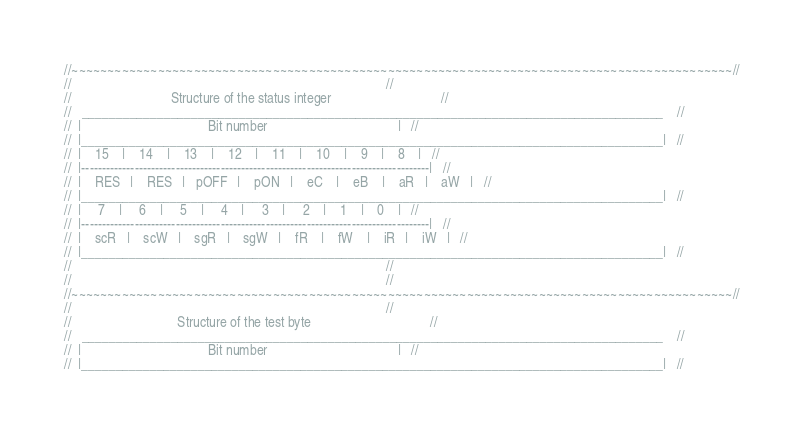Convert code to text. <code><loc_0><loc_0><loc_500><loc_500><_C++_>//~~~~~~~~~~~~~~~~~~~~~~~~~~~~~~~~~~~~~~~~~~~~~~~~~~~~~~~~~~~~~~~~~~~~~~~~~~~~~~~~~~~~~~~~~~~~//
//                                                                                            //
//                             Structure of the status integer                                //
//   _____________________________________________________________________________________    //
//  |                                     Bit number                                      |   //
//  |_____________________________________________________________________________________|   //
//  |    15    |    14    |    13    |    12    |    11    |    10    |    9    |    8    |   //
//  |-------------------------------------------------------------------------------------|   //
//  |    RES   |    RES   |   pOFF   |    pON   |    eC    |    eB    |    aR   |    aW   |   //
//  |_____________________________________________________________________________________|   //
//  |     7    |     6    |     5    |     4    |     3    |     2    |    1    |    0    |   //
//  |-------------------------------------------------------------------------------------|   //
//  |    scR   |    scW   |    sgR   |    sgW   |    fR    |    fW    |    iR   |    iW   |   //
//  |_____________________________________________________________________________________|   //
//                                                                                            //
//                                                                                            //
//~~~~~~~~~~~~~~~~~~~~~~~~~~~~~~~~~~~~~~~~~~~~~~~~~~~~~~~~~~~~~~~~~~~~~~~~~~~~~~~~~~~~~~~~~~~~//
//                                                                                            //
//                               Structure of the test byte                                   //
//   _____________________________________________________________________________________    //
//  |                                     Bit number                                      |   //
//  |_____________________________________________________________________________________|   //</code> 